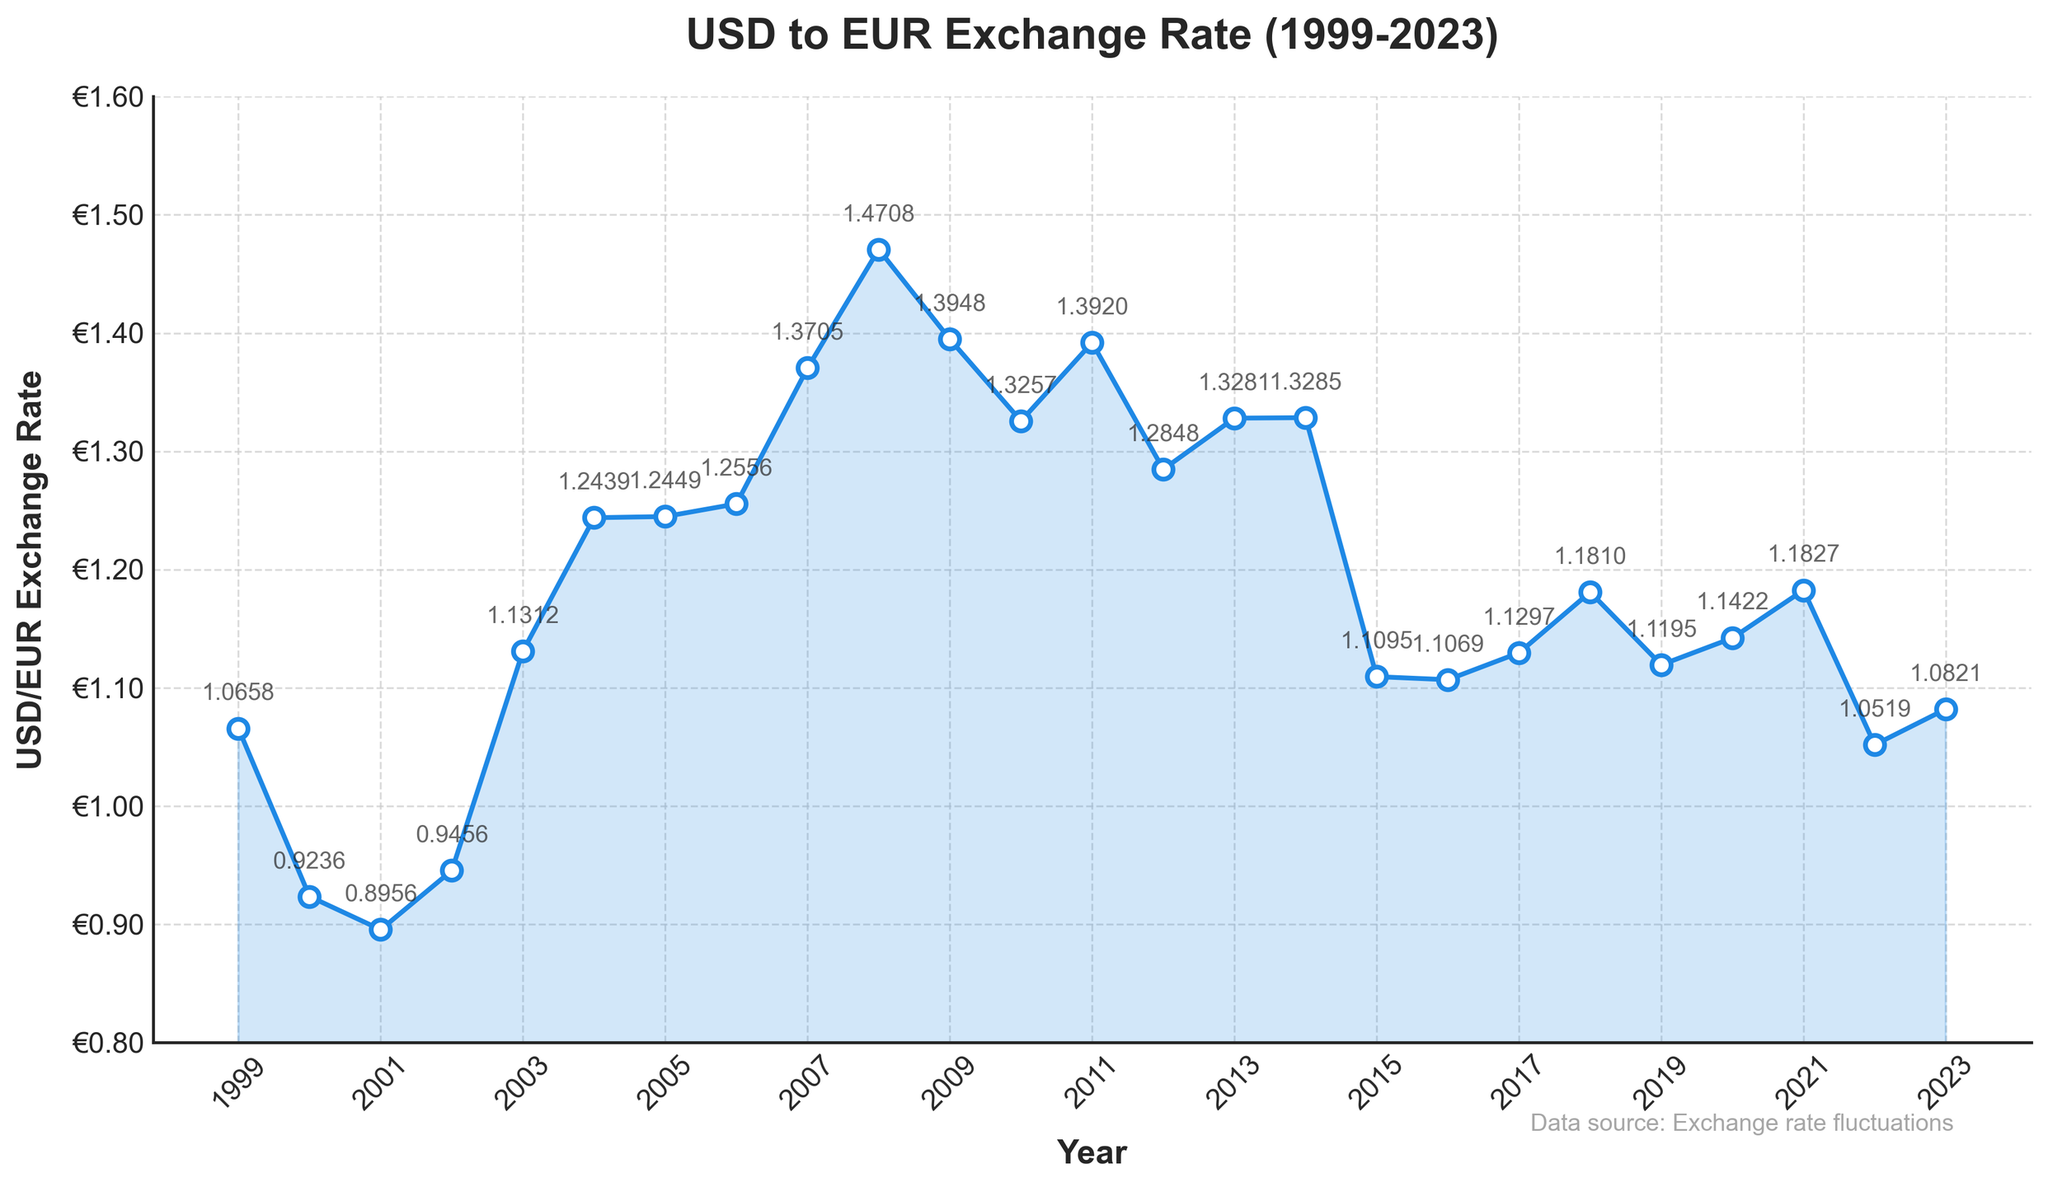What was the exchange rate in 2007? Locate the year 2007 on the x-axis and find the corresponding point on the line chart. The exchange rate is labeled next to the point.
Answer: 1.3705 How does the exchange rate in 2022 compare to that in 2002? Identify the points for 2022 and 2002 on the chart. 2022 shows a rate of 1.0519, while 2002 shows a rate of 0.9456. Therefore, the exchange rate in 2022 is higher than in 2002.
Answer: 2022 rate is higher What was the highest exchange rate recorded in the given time frame, and in which year did it occur? Visually inspect the peaks of the line. The highest peak occurs in 2008 with an exchange rate of 1.4708, which is also labeled on the graph.
Answer: 1.4708 in 2008 How did the exchange rate change from 2011 to 2012? Find the exchange rates for 2011 (1.3920) and 2012 (1.2848) on the chart. Subtract the 2012 rate from the 2011 rate: 1.3920 - 1.2848 = 0.1072. The exchange rate decreased by 0.1072.
Answer: Decreased by 0.1072 What is the average exchange rate over the period from 1999 to 2023? Collect the exchange rates from all years and sum them up: (1.0658 + 0.9236 + 0.8956 + 0.9456 + 1.1312 + 1.2439 + 1.2449 + 1.2556 + 1.3705 + 1.4708 + 1.3948 + 1.3257 + 1.3920 + 1.2848 + 1.3281 + 1.3285 + 1.1095 + 1.1069 + 1.1297 + 1.1810 + 1.1195 + 1.1422 + 1.1827 + 1.0519 + 1.0821) = 29.4071. Divide this sum by the number of years (25). The average is 29.4071 / 25 ≈ 1.1763.
Answer: 1.1763 In which period did the exchange rate have the largest drop, and what was the value of the drop? Look for the steepest downward slope in the line. From 2008 (1.4708) to 2009 (1.3948), the drop is 1.4708 - 1.3948 = 0.076. This is the largest visible drop.
Answer: 2008-2009, drop of 0.076 When was the exchange rate the closest to 1.0? Scan the line to identify the point closest to 1.0. In 1999, the exchange rate was 1.0658, which appears to be closest to 1.0 based on visual inspection.
Answer: 1999 How many times did the exchange rate go above 1.2? Count the segments of the line above the 1.2 mark throughout the period. The exchange rate is above 1.2 in the years 2003, 2004, 2005, 2006, 2008, 2009, 2010, 2011, 2013, 2014, 2017, 2018, 2019, 2020, and 2021, thus there are 15 occurrences.
Answer: 15 times From 2018 to 2021, did the exchange rate generally increase or decrease? Observe the trend of the line from 2018 (1.1810) to 2021 (1.1827). The overall trend shows a slight increase, indicating that the exchange rate generally increased in this period.
Answer: Increase Which years experienced a noticeable upward trend in exchange rates? Identify segments of the line with a consistent upward direction. The periods from 2001 to 2003 and from 2015 to 2018 show such upward trends.
Answer: 2001-2003, 2015-2018 